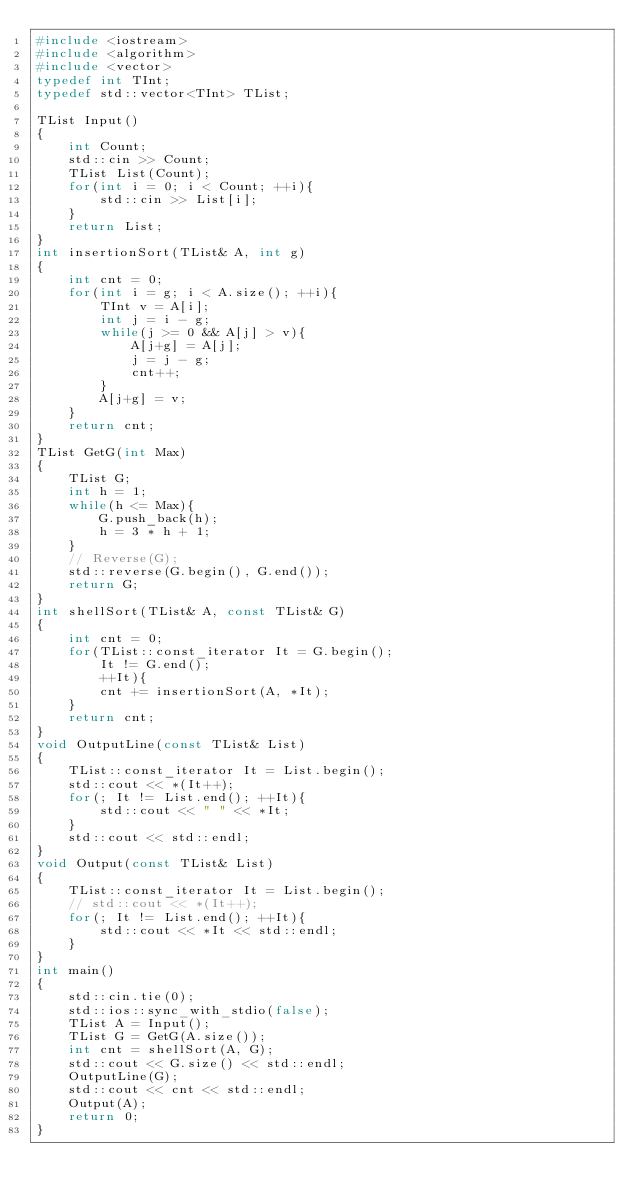<code> <loc_0><loc_0><loc_500><loc_500><_C++_>#include <iostream>
#include <algorithm>
#include <vector>
typedef int TInt;
typedef std::vector<TInt> TList;

TList Input()
{
    int Count;
    std::cin >> Count;
    TList List(Count);
    for(int i = 0; i < Count; ++i){
        std::cin >> List[i];
    }
    return List;
}
int insertionSort(TList& A, int g)
{
    int cnt = 0;
    for(int i = g; i < A.size(); ++i){
        TInt v = A[i];
        int j = i - g;
        while(j >= 0 && A[j] > v){
            A[j+g] = A[j];
            j = j - g;
            cnt++;
        }
        A[j+g] = v;
    }
    return cnt;
}
TList GetG(int Max)
{
    TList G;
    int h = 1;
    while(h <= Max){
        G.push_back(h);
        h = 3 * h + 1;
    }
    // Reverse(G);
    std::reverse(G.begin(), G.end());
    return G;
}
int shellSort(TList& A, const TList& G)
{
    int cnt = 0;
    for(TList::const_iterator It = G.begin();
        It != G.end();
        ++It){
        cnt += insertionSort(A, *It);
    }
    return cnt;
}
void OutputLine(const TList& List)
{
    TList::const_iterator It = List.begin();
    std::cout << *(It++);
    for(; It != List.end(); ++It){
        std::cout << " " << *It;
    }
    std::cout << std::endl;
}
void Output(const TList& List)
{
    TList::const_iterator It = List.begin();
    // std::cout << *(It++);
    for(; It != List.end(); ++It){
        std::cout << *It << std::endl;
    }
}
int main()
{
    std::cin.tie(0);
    std::ios::sync_with_stdio(false);
    TList A = Input();
    TList G = GetG(A.size());
    int cnt = shellSort(A, G);
    std::cout << G.size() << std::endl;
    OutputLine(G);
    std::cout << cnt << std::endl;
    Output(A);
    return 0;   
}</code> 